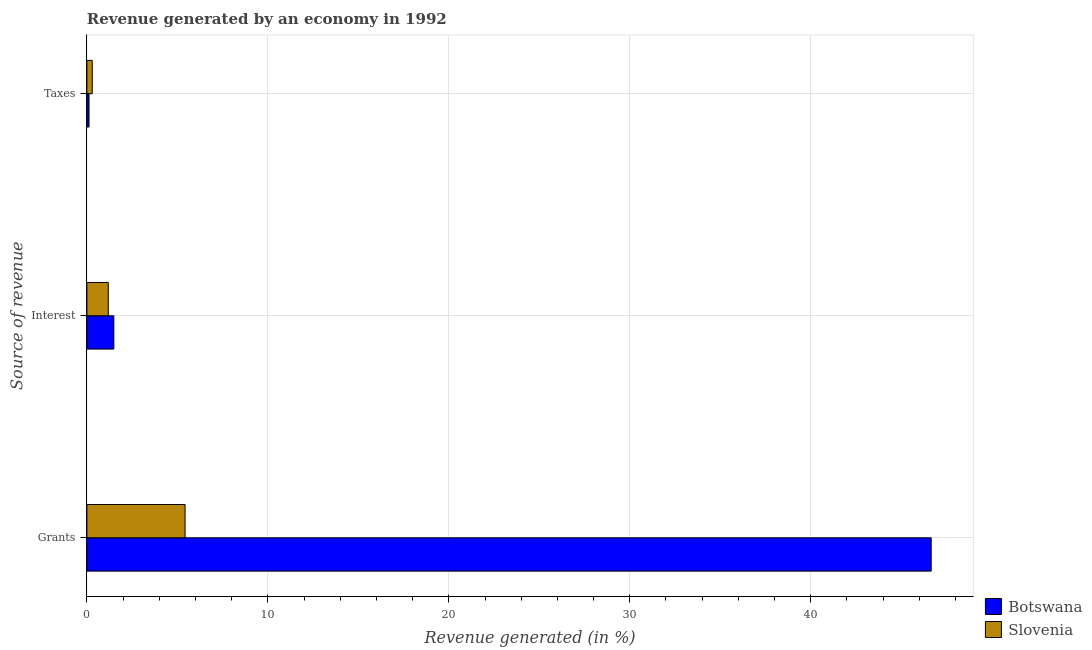How many different coloured bars are there?
Your answer should be very brief. 2. What is the label of the 3rd group of bars from the top?
Keep it short and to the point. Grants. What is the percentage of revenue generated by interest in Botswana?
Give a very brief answer. 1.49. Across all countries, what is the maximum percentage of revenue generated by grants?
Make the answer very short. 46.65. Across all countries, what is the minimum percentage of revenue generated by taxes?
Provide a succinct answer. 0.12. In which country was the percentage of revenue generated by taxes maximum?
Make the answer very short. Slovenia. In which country was the percentage of revenue generated by grants minimum?
Offer a very short reply. Slovenia. What is the total percentage of revenue generated by interest in the graph?
Your response must be concise. 2.67. What is the difference between the percentage of revenue generated by taxes in Botswana and that in Slovenia?
Your answer should be compact. -0.18. What is the difference between the percentage of revenue generated by taxes in Botswana and the percentage of revenue generated by interest in Slovenia?
Provide a short and direct response. -1.07. What is the average percentage of revenue generated by taxes per country?
Your answer should be very brief. 0.21. What is the difference between the percentage of revenue generated by taxes and percentage of revenue generated by grants in Botswana?
Offer a very short reply. -46.54. In how many countries, is the percentage of revenue generated by interest greater than 14 %?
Provide a short and direct response. 0. What is the ratio of the percentage of revenue generated by taxes in Slovenia to that in Botswana?
Your response must be concise. 2.5. What is the difference between the highest and the second highest percentage of revenue generated by interest?
Your response must be concise. 0.31. What is the difference between the highest and the lowest percentage of revenue generated by interest?
Offer a very short reply. 0.31. What does the 1st bar from the top in Taxes represents?
Your response must be concise. Slovenia. What does the 2nd bar from the bottom in Taxes represents?
Make the answer very short. Slovenia. Is it the case that in every country, the sum of the percentage of revenue generated by grants and percentage of revenue generated by interest is greater than the percentage of revenue generated by taxes?
Your answer should be very brief. Yes. Where does the legend appear in the graph?
Provide a succinct answer. Bottom right. How many legend labels are there?
Offer a very short reply. 2. How are the legend labels stacked?
Your answer should be compact. Vertical. What is the title of the graph?
Provide a short and direct response. Revenue generated by an economy in 1992. Does "St. Lucia" appear as one of the legend labels in the graph?
Your answer should be very brief. No. What is the label or title of the X-axis?
Provide a short and direct response. Revenue generated (in %). What is the label or title of the Y-axis?
Give a very brief answer. Source of revenue. What is the Revenue generated (in %) in Botswana in Grants?
Provide a short and direct response. 46.65. What is the Revenue generated (in %) in Slovenia in Grants?
Give a very brief answer. 5.43. What is the Revenue generated (in %) of Botswana in Interest?
Your answer should be very brief. 1.49. What is the Revenue generated (in %) of Slovenia in Interest?
Give a very brief answer. 1.18. What is the Revenue generated (in %) in Botswana in Taxes?
Ensure brevity in your answer.  0.12. What is the Revenue generated (in %) of Slovenia in Taxes?
Your answer should be compact. 0.3. Across all Source of revenue, what is the maximum Revenue generated (in %) in Botswana?
Keep it short and to the point. 46.65. Across all Source of revenue, what is the maximum Revenue generated (in %) of Slovenia?
Provide a succinct answer. 5.43. Across all Source of revenue, what is the minimum Revenue generated (in %) of Botswana?
Give a very brief answer. 0.12. Across all Source of revenue, what is the minimum Revenue generated (in %) of Slovenia?
Keep it short and to the point. 0.3. What is the total Revenue generated (in %) in Botswana in the graph?
Offer a terse response. 48.26. What is the total Revenue generated (in %) of Slovenia in the graph?
Your response must be concise. 6.91. What is the difference between the Revenue generated (in %) of Botswana in Grants and that in Interest?
Provide a short and direct response. 45.17. What is the difference between the Revenue generated (in %) of Slovenia in Grants and that in Interest?
Provide a short and direct response. 4.24. What is the difference between the Revenue generated (in %) in Botswana in Grants and that in Taxes?
Offer a very short reply. 46.54. What is the difference between the Revenue generated (in %) of Slovenia in Grants and that in Taxes?
Make the answer very short. 5.13. What is the difference between the Revenue generated (in %) in Botswana in Interest and that in Taxes?
Your answer should be compact. 1.37. What is the difference between the Revenue generated (in %) of Slovenia in Interest and that in Taxes?
Ensure brevity in your answer.  0.89. What is the difference between the Revenue generated (in %) in Botswana in Grants and the Revenue generated (in %) in Slovenia in Interest?
Provide a succinct answer. 45.47. What is the difference between the Revenue generated (in %) of Botswana in Grants and the Revenue generated (in %) of Slovenia in Taxes?
Give a very brief answer. 46.36. What is the difference between the Revenue generated (in %) in Botswana in Interest and the Revenue generated (in %) in Slovenia in Taxes?
Ensure brevity in your answer.  1.19. What is the average Revenue generated (in %) of Botswana per Source of revenue?
Your answer should be compact. 16.09. What is the average Revenue generated (in %) of Slovenia per Source of revenue?
Your response must be concise. 2.3. What is the difference between the Revenue generated (in %) in Botswana and Revenue generated (in %) in Slovenia in Grants?
Provide a short and direct response. 41.23. What is the difference between the Revenue generated (in %) of Botswana and Revenue generated (in %) of Slovenia in Interest?
Give a very brief answer. 0.31. What is the difference between the Revenue generated (in %) in Botswana and Revenue generated (in %) in Slovenia in Taxes?
Keep it short and to the point. -0.18. What is the ratio of the Revenue generated (in %) in Botswana in Grants to that in Interest?
Make the answer very short. 31.33. What is the ratio of the Revenue generated (in %) of Slovenia in Grants to that in Interest?
Your response must be concise. 4.58. What is the ratio of the Revenue generated (in %) of Botswana in Grants to that in Taxes?
Give a very brief answer. 394.52. What is the ratio of the Revenue generated (in %) of Slovenia in Grants to that in Taxes?
Keep it short and to the point. 18.33. What is the ratio of the Revenue generated (in %) in Botswana in Interest to that in Taxes?
Your response must be concise. 12.59. What is the difference between the highest and the second highest Revenue generated (in %) of Botswana?
Make the answer very short. 45.17. What is the difference between the highest and the second highest Revenue generated (in %) in Slovenia?
Give a very brief answer. 4.24. What is the difference between the highest and the lowest Revenue generated (in %) of Botswana?
Offer a terse response. 46.54. What is the difference between the highest and the lowest Revenue generated (in %) in Slovenia?
Your answer should be compact. 5.13. 